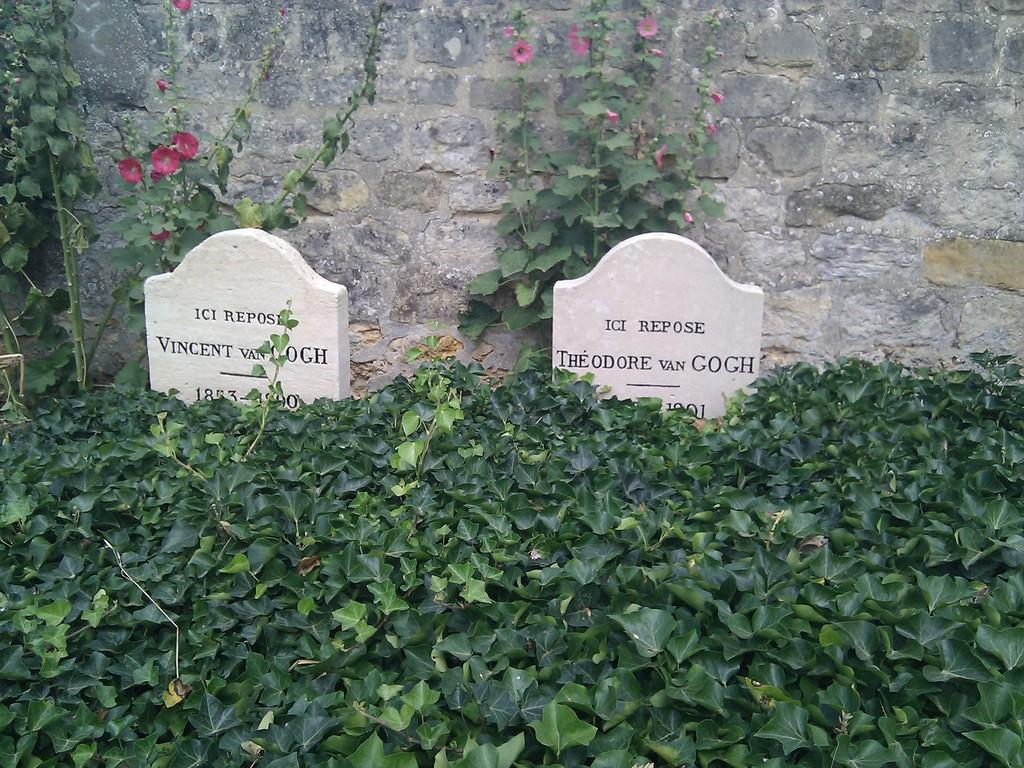<image>
Relay a brief, clear account of the picture shown. The burial place of Vincent Van Gogh is nearly covered in plant growth. 